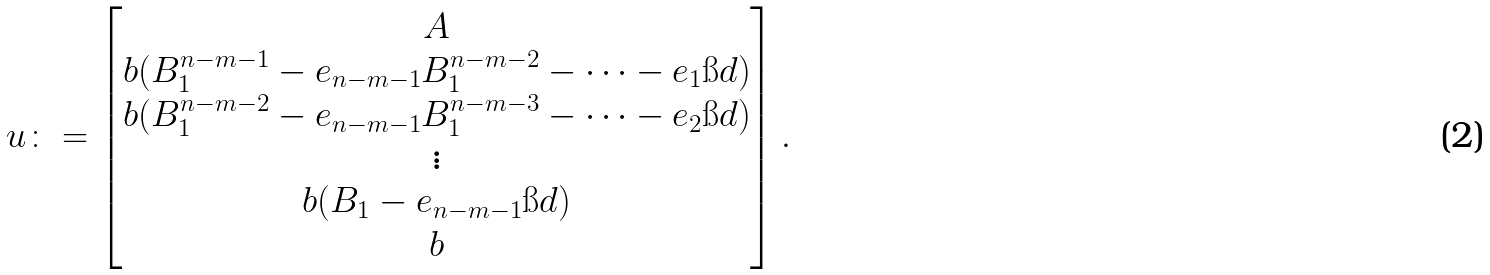Convert formula to latex. <formula><loc_0><loc_0><loc_500><loc_500>u \colon = \begin{bmatrix} A \\ b ( B _ { 1 } ^ { n - m - 1 } - e _ { n - m - 1 } B _ { 1 } ^ { n - m - 2 } - \cdots - e _ { 1 } \i d ) \\ b ( B _ { 1 } ^ { n - m - 2 } - e _ { n - m - 1 } B _ { 1 } ^ { n - m - 3 } - \cdots - e _ { 2 } \i d ) \\ \vdots \\ b ( B _ { 1 } - e _ { n - m - 1 } \i d ) \\ b \end{bmatrix} .</formula> 